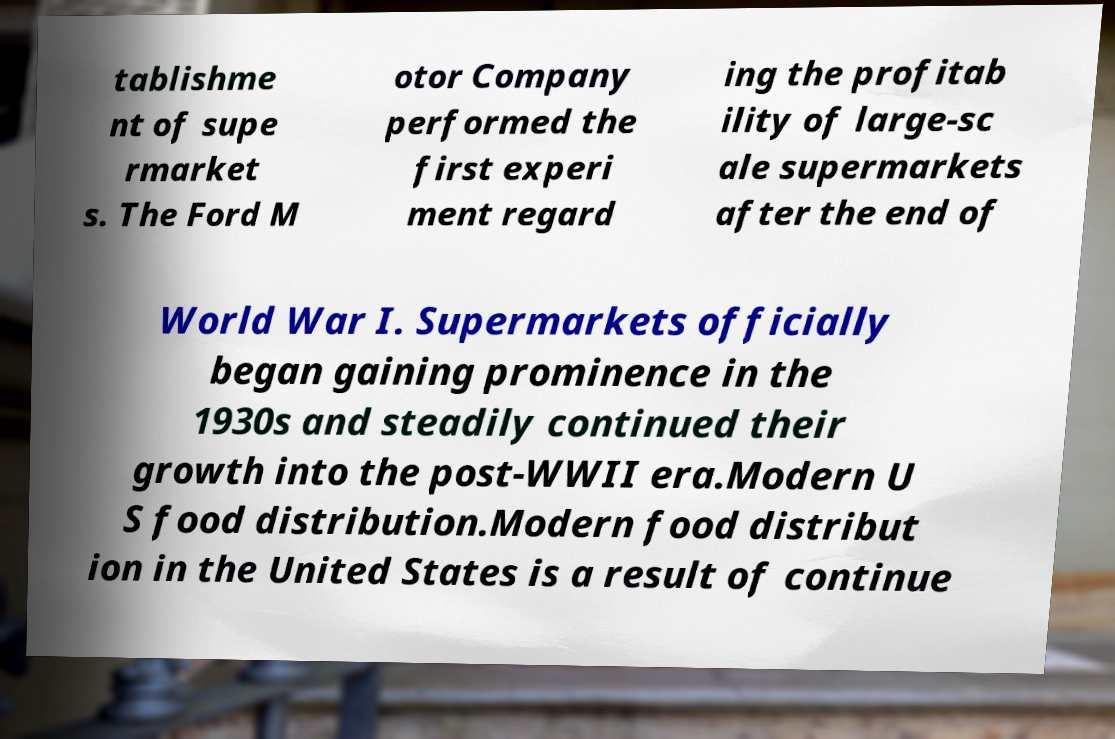I need the written content from this picture converted into text. Can you do that? tablishme nt of supe rmarket s. The Ford M otor Company performed the first experi ment regard ing the profitab ility of large-sc ale supermarkets after the end of World War I. Supermarkets officially began gaining prominence in the 1930s and steadily continued their growth into the post-WWII era.Modern U S food distribution.Modern food distribut ion in the United States is a result of continue 